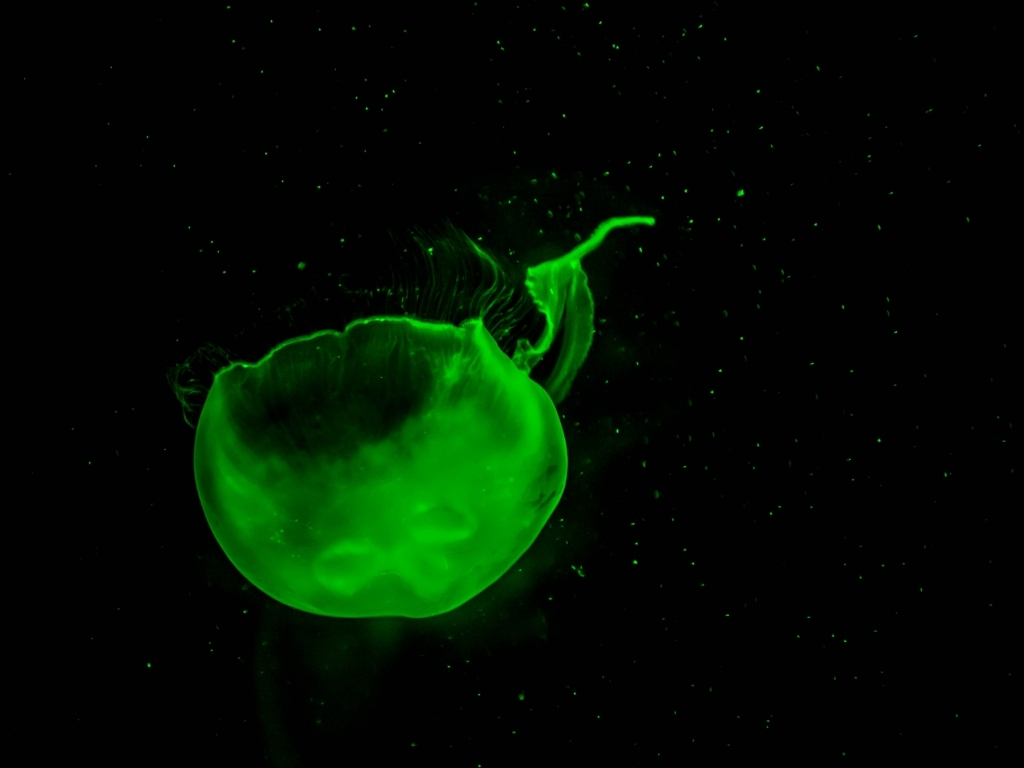Could you tell me more about the technique used to capture this kind of image? To capture images of bioluminescent organisms like jellyfish, photographers often use low-light camera settings and long exposures to enable the sensor to collect enough light. They may also employ macro lenses for close-up detail or wide apertures to focus sharply on the subject while keeping the background dark. Special care is taken to prevent camera shake and to not disturb the natural behavior of the jellyfish. 